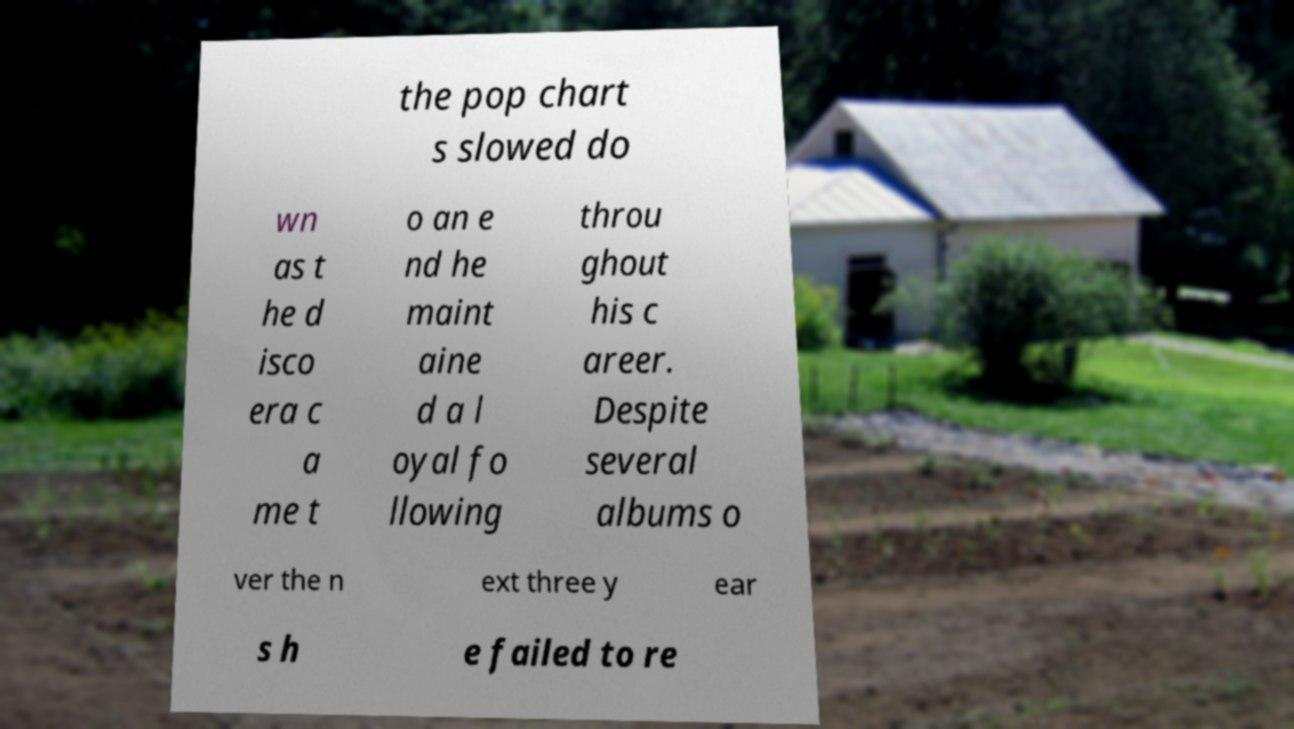Could you assist in decoding the text presented in this image and type it out clearly? the pop chart s slowed do wn as t he d isco era c a me t o an e nd he maint aine d a l oyal fo llowing throu ghout his c areer. Despite several albums o ver the n ext three y ear s h e failed to re 